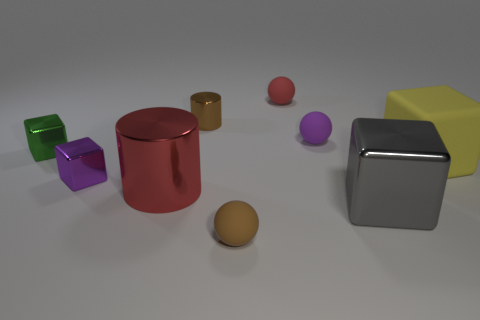Add 1 big objects. How many objects exist? 10 Subtract all yellow rubber blocks. How many blocks are left? 3 Subtract 1 green cubes. How many objects are left? 8 Subtract all cylinders. How many objects are left? 7 Subtract 2 cylinders. How many cylinders are left? 0 Subtract all red cylinders. Subtract all cyan spheres. How many cylinders are left? 1 Subtract all purple cylinders. How many cyan balls are left? 0 Subtract all tiny red cubes. Subtract all metal things. How many objects are left? 4 Add 6 green shiny cubes. How many green shiny cubes are left? 7 Add 5 yellow cubes. How many yellow cubes exist? 6 